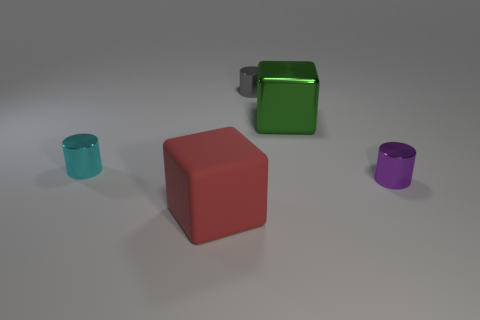Subtract all gray cylinders. How many cylinders are left? 2 Add 2 cylinders. How many objects exist? 7 Subtract all cubes. How many objects are left? 3 Subtract 0 blue cylinders. How many objects are left? 5 Subtract all tiny shiny cylinders. Subtract all green metallic objects. How many objects are left? 1 Add 3 cyan metallic cylinders. How many cyan metallic cylinders are left? 4 Add 1 large blue matte blocks. How many large blue matte blocks exist? 1 